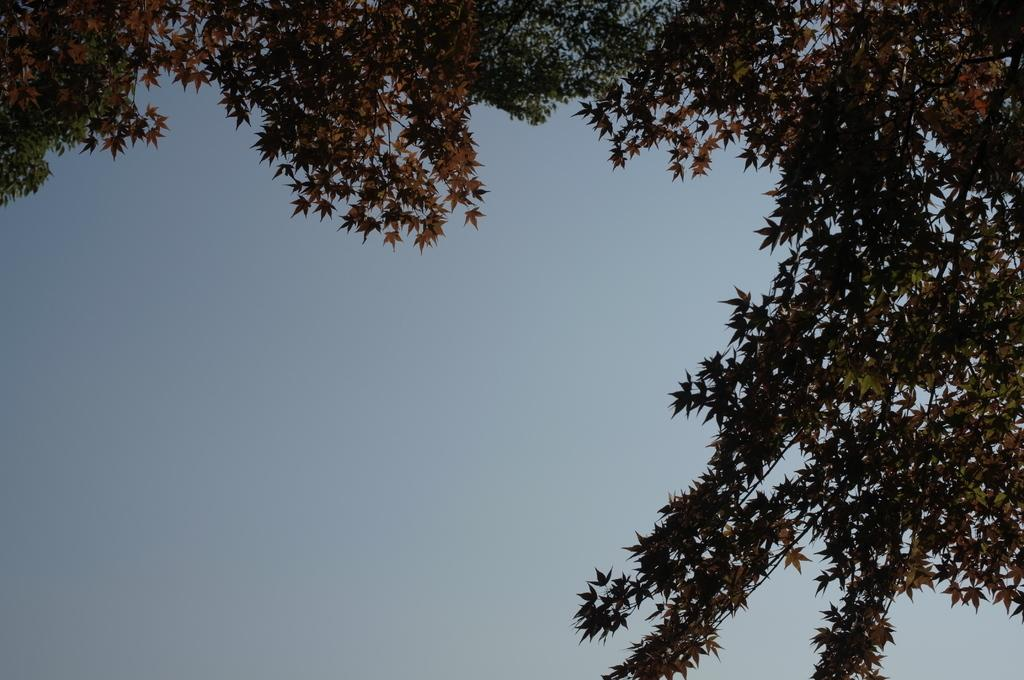What type of vegetation can be seen in the image? There are trees in the image. What part of the natural environment is visible in the image? The sky is visible in the background of the image. How many fans can be seen in the image? There are no fans present in the image. What type of nose is visible on the tree in the image? There are no noses present on the trees in the image, as trees do not have noses. 